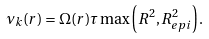<formula> <loc_0><loc_0><loc_500><loc_500>\nu _ { k } ( r ) = \Omega ( r ) \tau \max \left ( R ^ { 2 } , R _ { e p i } ^ { 2 } \right ) .</formula> 